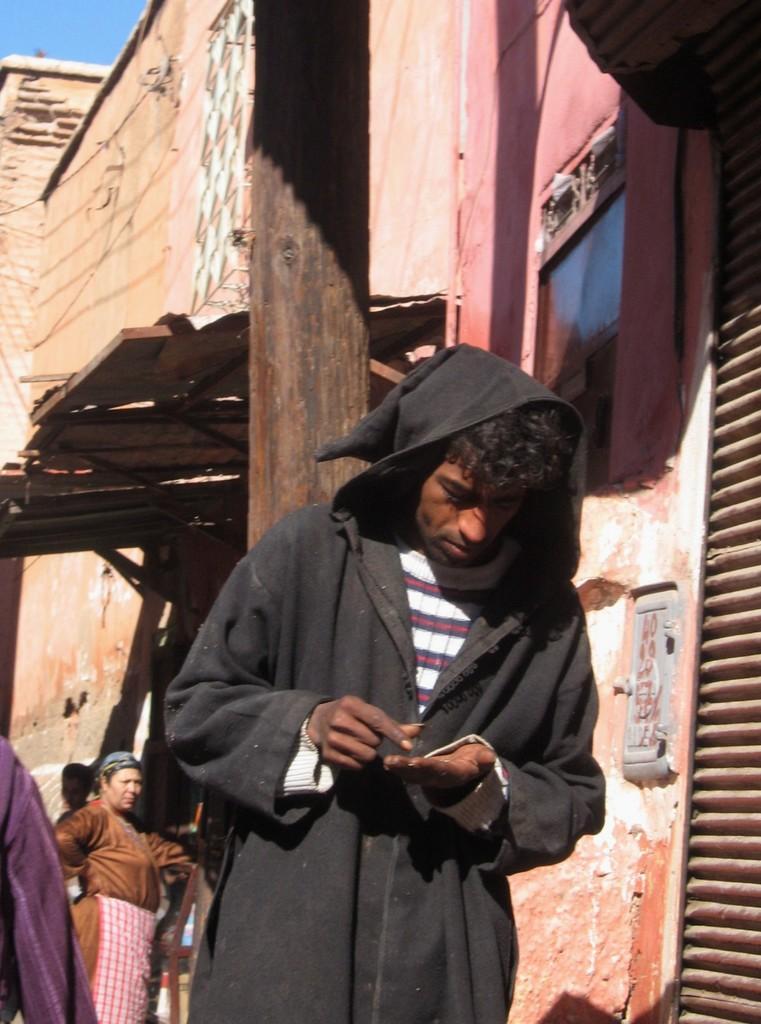In one or two sentences, can you explain what this image depicts? In the picture we can see a man standing and wearing a black color hoodie with a cap near to the house and behind him we can see some people are also standing and we can also see a part of the sky on the top of the house. 